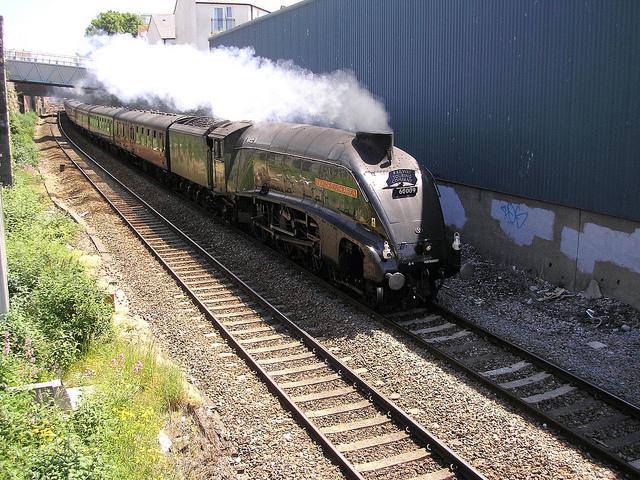Is this a new train?
Give a very brief answer. Yes. Is the engine steam or diesel?
Quick response, please. Steam. What is coming out of the train?
Give a very brief answer. Steam. What is the train riding on?
Give a very brief answer. Tracks. Is this a steam engine?
Quick response, please. Yes. 